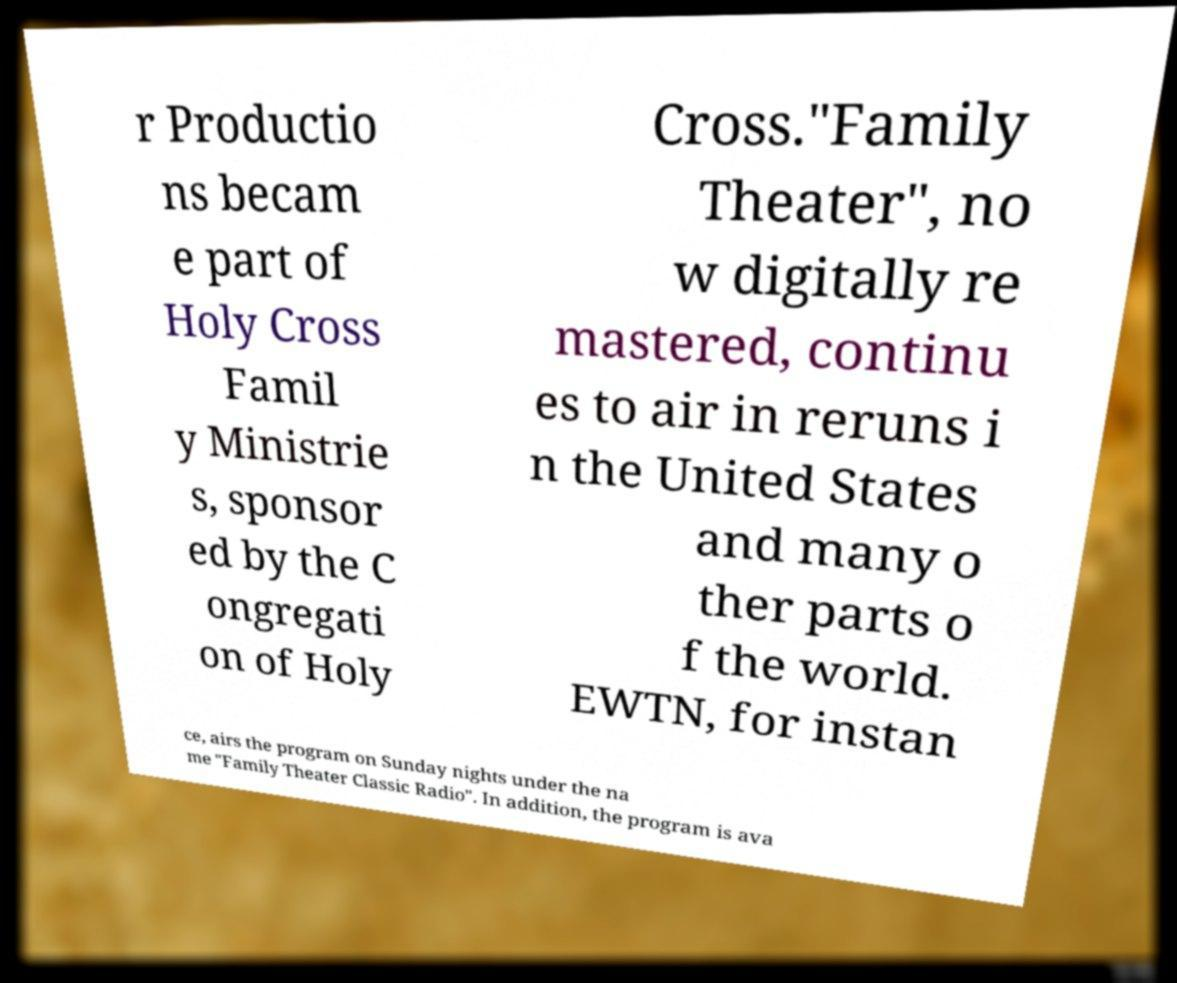For documentation purposes, I need the text within this image transcribed. Could you provide that? r Productio ns becam e part of Holy Cross Famil y Ministrie s, sponsor ed by the C ongregati on of Holy Cross."Family Theater", no w digitally re mastered, continu es to air in reruns i n the United States and many o ther parts o f the world. EWTN, for instan ce, airs the program on Sunday nights under the na me "Family Theater Classic Radio". In addition, the program is ava 